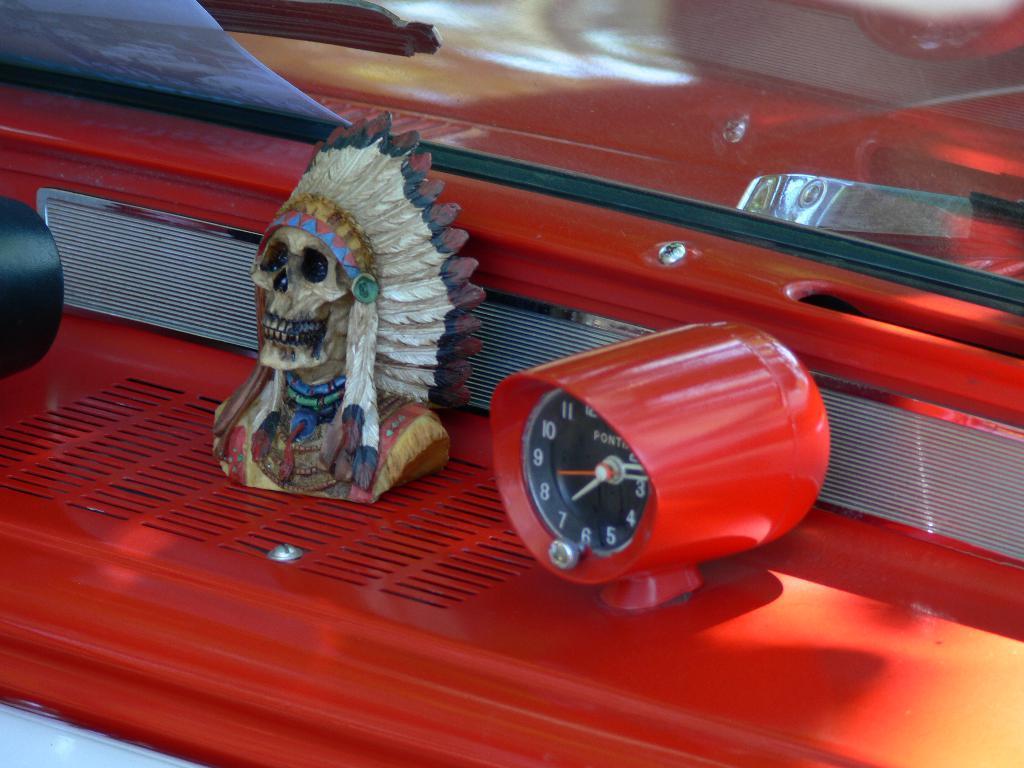Can you describe this image briefly? In this image we can see a clock, sculpture and a paper placed on the red color surface. 